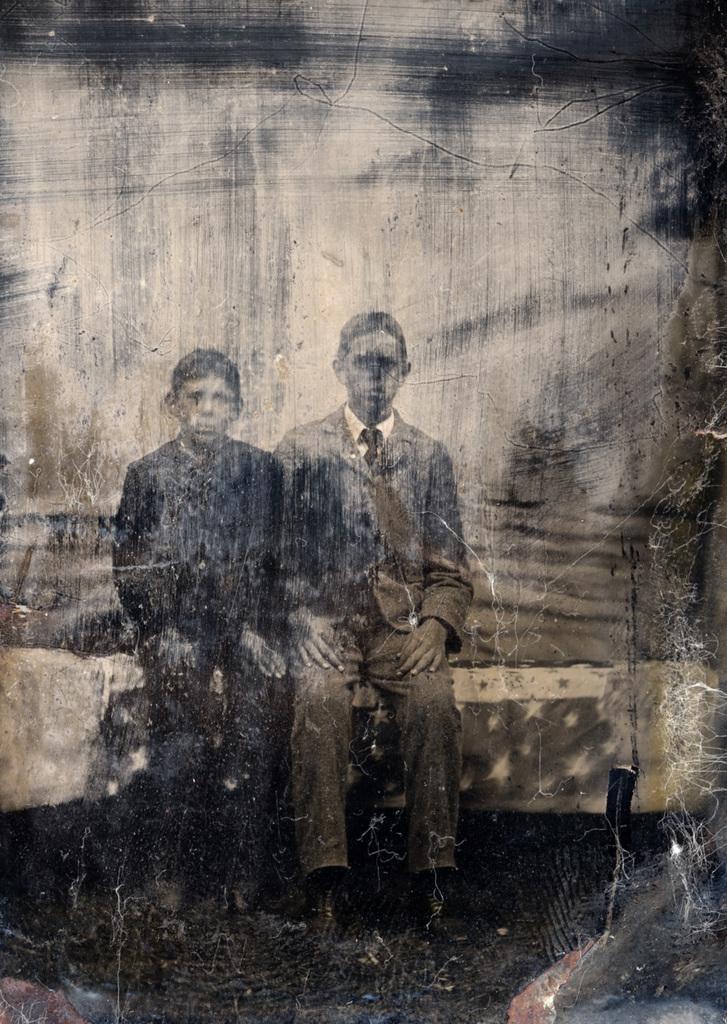Describe this image in one or two sentences. In this image we can see a photo of two persons sitting on some object. 